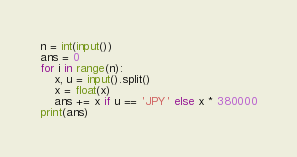<code> <loc_0><loc_0><loc_500><loc_500><_Python_>n = int(input())
ans = 0
for i in range(n):
    x, u = input().split()
    x = float(x)
    ans += x if u == 'JPY' else x * 380000
print(ans)</code> 